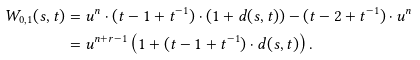Convert formula to latex. <formula><loc_0><loc_0><loc_500><loc_500>W _ { 0 , 1 } ( s , t ) & = u ^ { n } \cdot ( t - 1 + t ^ { - 1 } ) \cdot \left ( 1 + d ( s , t ) \right ) - ( t - 2 + t ^ { - 1 } ) \cdot u ^ { n } \\ & = u ^ { n + r - 1 } \left ( 1 + ( t - 1 + t ^ { - 1 } ) \cdot d ( s , t ) \right ) .</formula> 